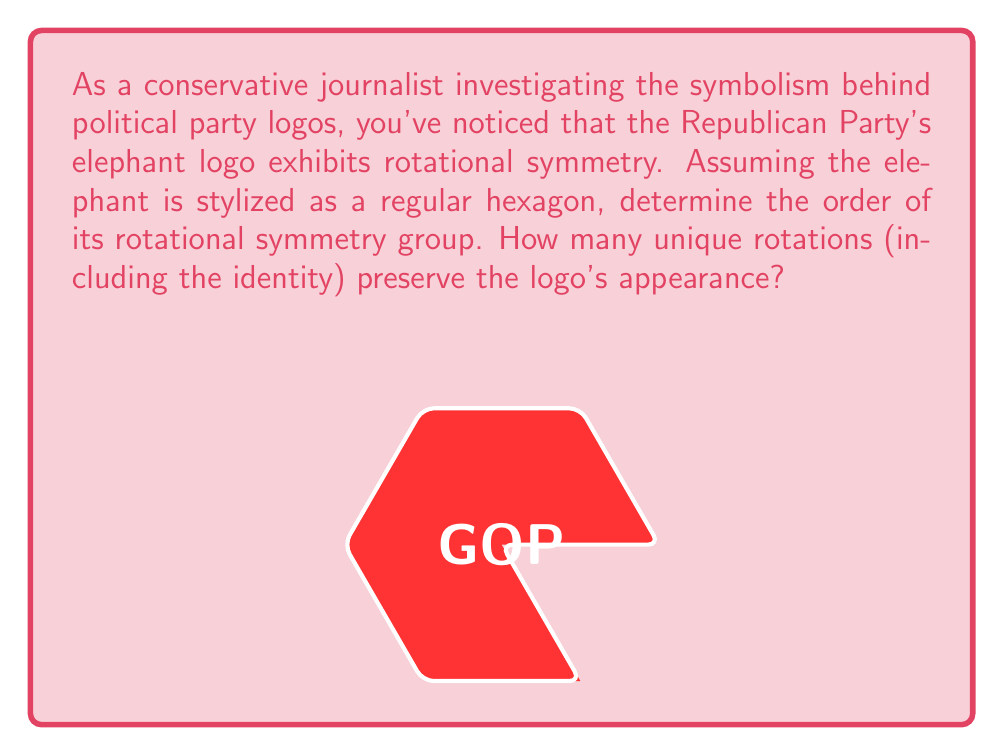Show me your answer to this math problem. To determine the order of the rotational symmetry group for a regular hexagon, we need to consider the following steps:

1) The order of a rotational symmetry group is the number of distinct rotations that leave the shape unchanged, including the identity rotation (0°).

2) For a regular n-gon, the possible rotations are multiples of $\frac{360°}{n}$.

3) In this case, n = 6 (hexagon), so the rotations are multiples of $\frac{360°}{6} = 60°$.

4) The distinct rotations are:
   - 0° (identity)
   - 60°
   - 120°
   - 180°
   - 240°
   - 300°

5) After a 360° rotation, we return to the starting position, which is equivalent to the identity rotation.

6) Therefore, there are 6 distinct rotations that preserve the hexagon's appearance.

The order of the rotational symmetry group is thus 6, which in group theory is denoted as $|C_6|$ or $|D_6|$ (depending on whether we're considering only rotations or both rotations and reflections).
Answer: 6 